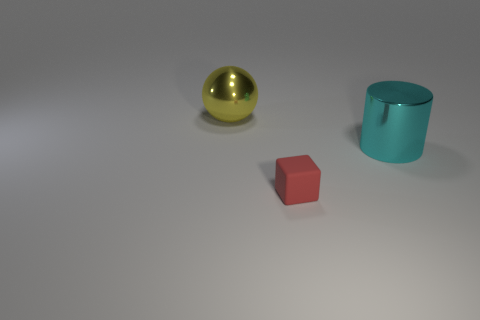Add 2 large cylinders. How many objects exist? 5 Subtract all blocks. How many objects are left? 2 Subtract all cyan metal objects. Subtract all rubber things. How many objects are left? 1 Add 1 small red matte objects. How many small red matte objects are left? 2 Add 1 small blue rubber blocks. How many small blue rubber blocks exist? 1 Subtract 0 red spheres. How many objects are left? 3 Subtract 1 cylinders. How many cylinders are left? 0 